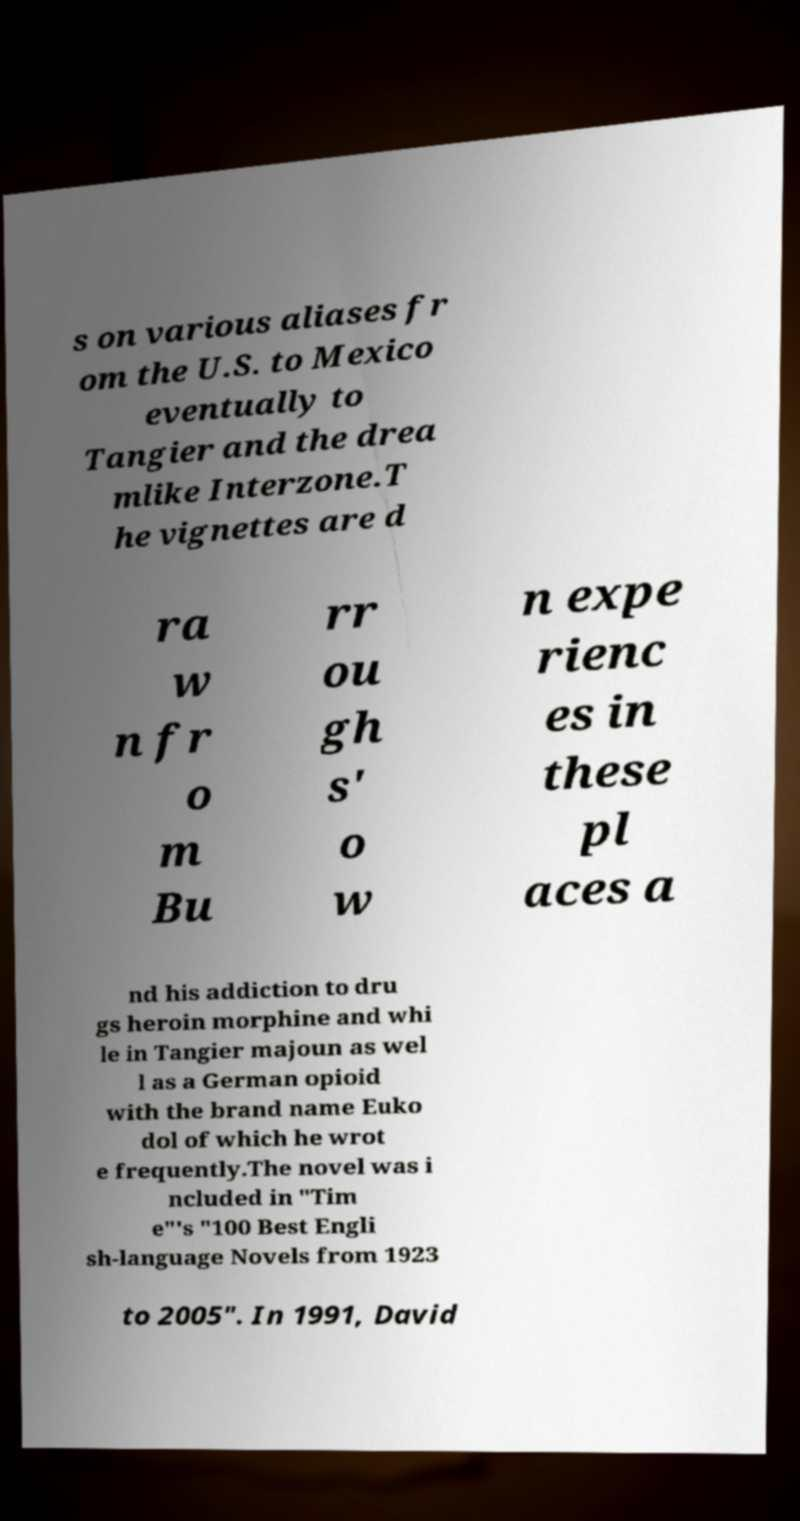Please read and relay the text visible in this image. What does it say? s on various aliases fr om the U.S. to Mexico eventually to Tangier and the drea mlike Interzone.T he vignettes are d ra w n fr o m Bu rr ou gh s' o w n expe rienc es in these pl aces a nd his addiction to dru gs heroin morphine and whi le in Tangier majoun as wel l as a German opioid with the brand name Euko dol of which he wrot e frequently.The novel was i ncluded in "Tim e"'s "100 Best Engli sh-language Novels from 1923 to 2005". In 1991, David 